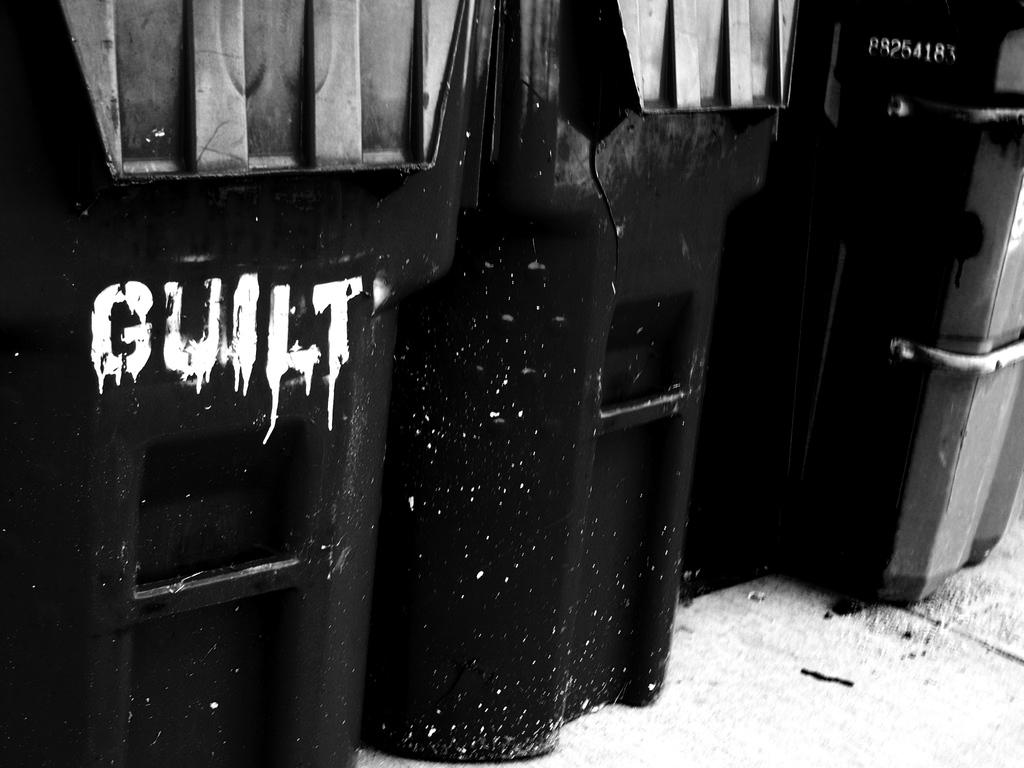What is the first number on the trash can on the right?
Offer a terse response. 8. What is written on the trash can?
Your answer should be compact. Guilt. 